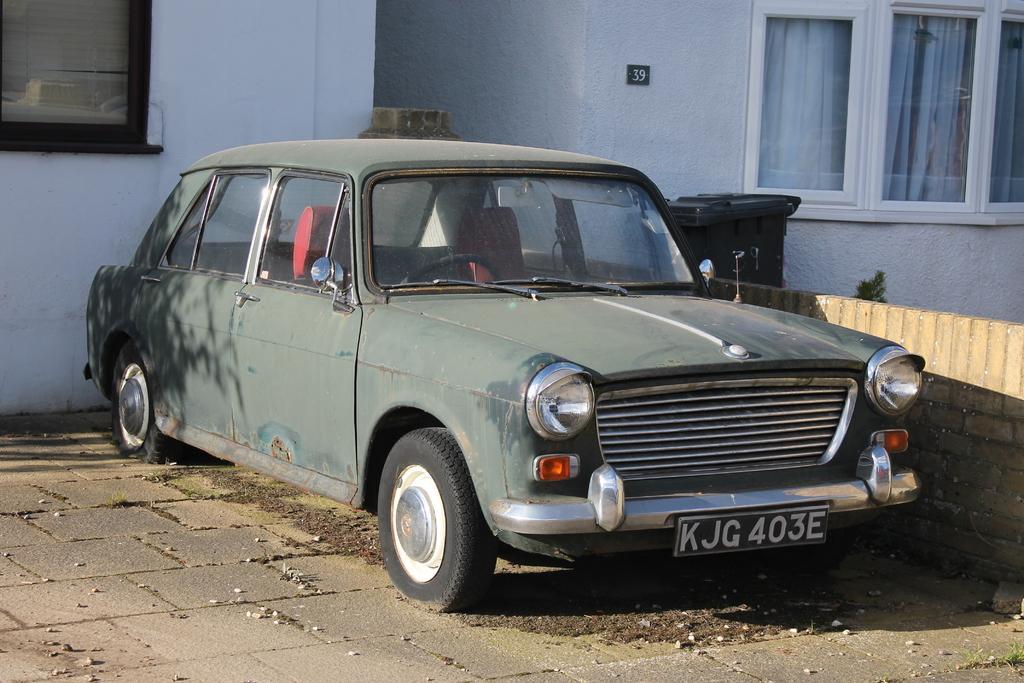Can you describe this image briefly? In this image we can see the vehicle parked on the path. We can also see the buildings with the windows and also the number board. Image also consists of a trash bin, plant and also the brick wall. We can also see the stones on the path. 